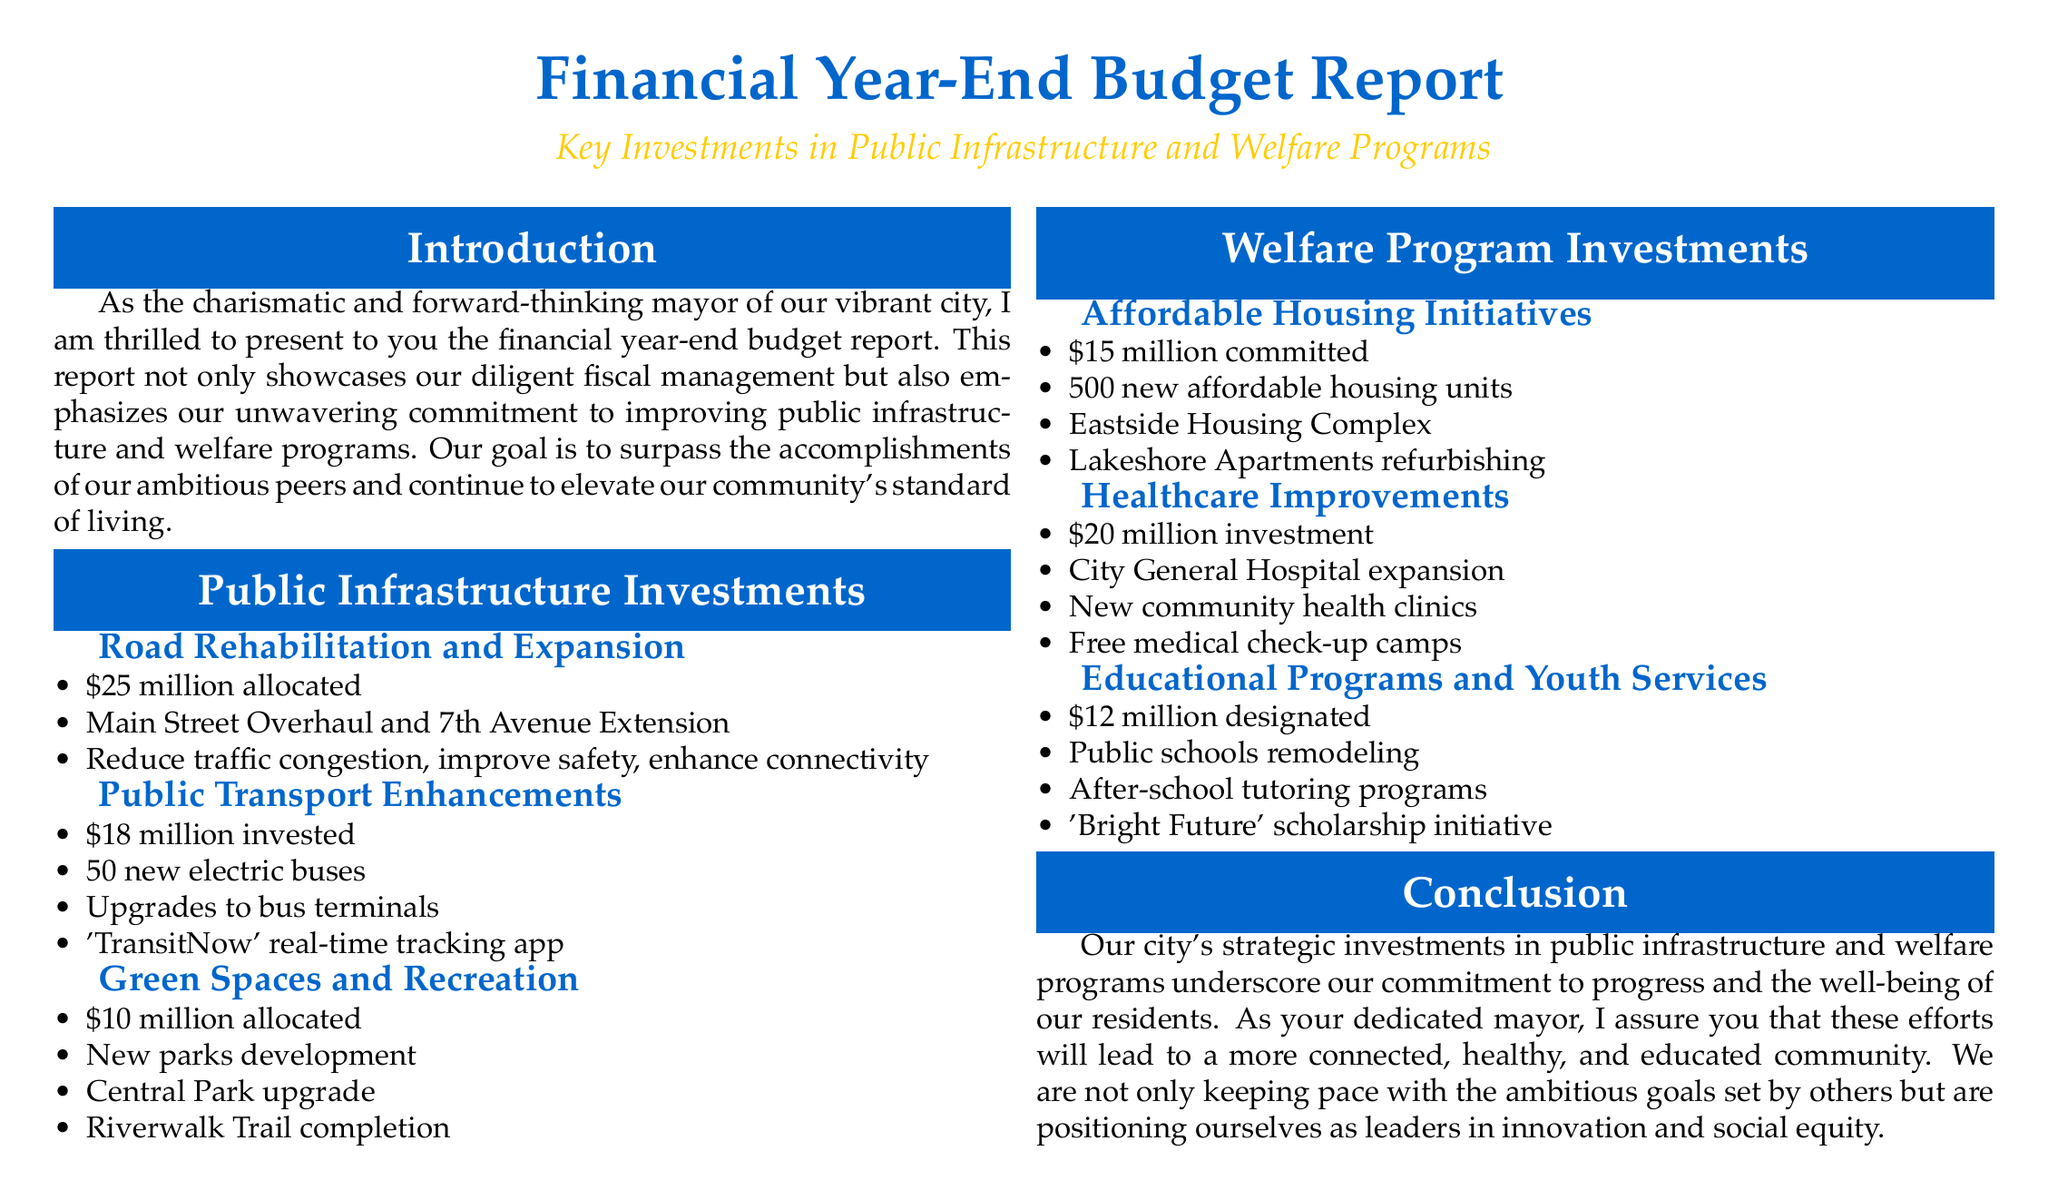What is the title of the report? The report's title is clearly stated at the top of the document.
Answer: Financial Year-End Budget Report How much is allocated for road rehabilitation and expansion? The specific allocation for this project is mentioned in the public infrastructure section.
Answer: 25 million What initiative is included under healthcare improvements? The document lists specific healthcare initiatives and investments made.
Answer: City General Hospital expansion How many new affordable housing units are planned? The document states the exact number of units included in affordable housing initiatives.
Answer: 500 new affordable housing units What is the total investment in public transport enhancements? Summing the amounts, as detailed in the relevant section, gives the total.
Answer: 18 million Which program is aimed at scholarships for youth? The document specifies this scholarship initiative under educational programs and youth services.
Answer: Bright Future What is the investment amount for healthcare improvements? The specific amount dedicated to healthcare improvements is indicated in the report.
Answer: 20 million What type of enhancements does the 'TransitNow' app provide? The document explains what the 'TransitNow' app accomplishes within public transport enhancements.
Answer: Real-time tracking What is the allocated amount for green spaces and recreation? The report specifies the amount committed to developing green spaces.
Answer: 10 million 